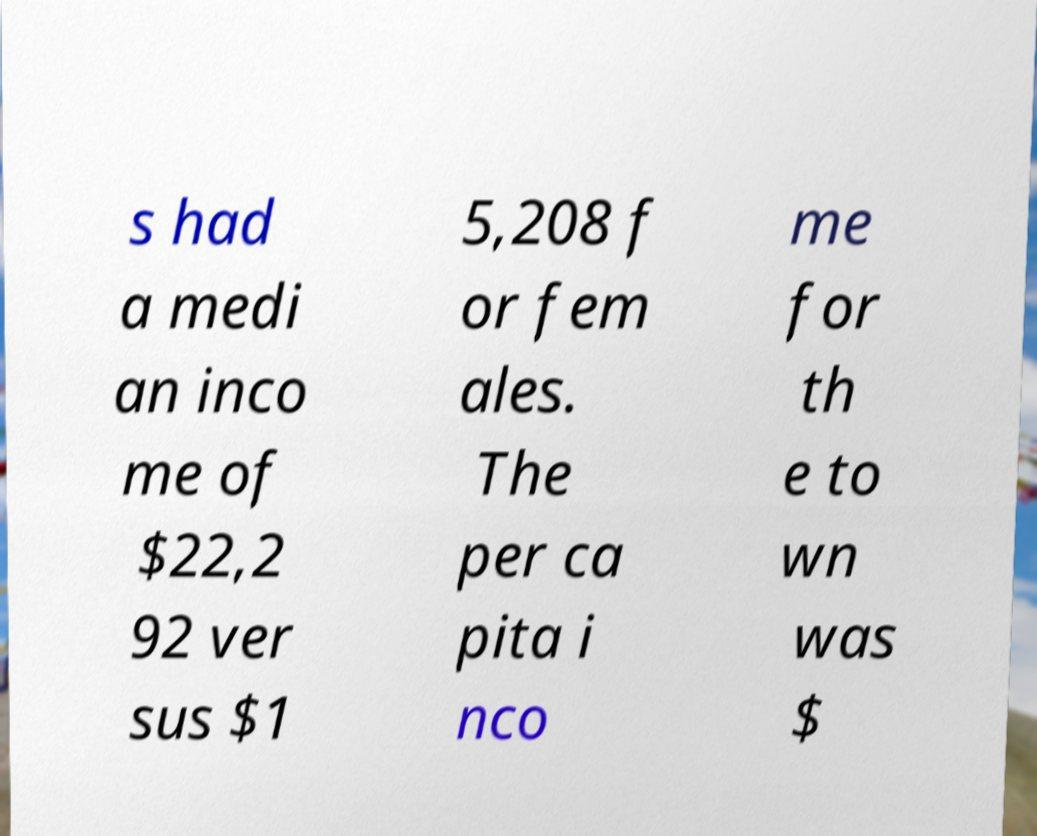For documentation purposes, I need the text within this image transcribed. Could you provide that? s had a medi an inco me of $22,2 92 ver sus $1 5,208 f or fem ales. The per ca pita i nco me for th e to wn was $ 